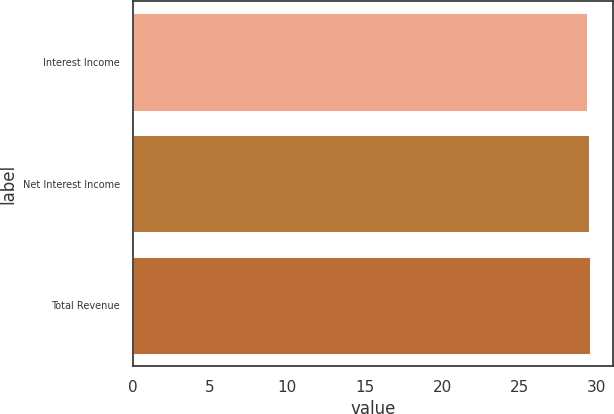Convert chart to OTSL. <chart><loc_0><loc_0><loc_500><loc_500><bar_chart><fcel>Interest Income<fcel>Net Interest Income<fcel>Total Revenue<nl><fcel>29.4<fcel>29.5<fcel>29.6<nl></chart> 